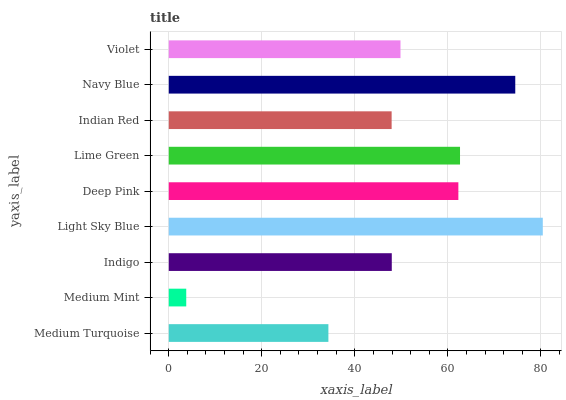Is Medium Mint the minimum?
Answer yes or no. Yes. Is Light Sky Blue the maximum?
Answer yes or no. Yes. Is Indigo the minimum?
Answer yes or no. No. Is Indigo the maximum?
Answer yes or no. No. Is Indigo greater than Medium Mint?
Answer yes or no. Yes. Is Medium Mint less than Indigo?
Answer yes or no. Yes. Is Medium Mint greater than Indigo?
Answer yes or no. No. Is Indigo less than Medium Mint?
Answer yes or no. No. Is Violet the high median?
Answer yes or no. Yes. Is Violet the low median?
Answer yes or no. Yes. Is Light Sky Blue the high median?
Answer yes or no. No. Is Deep Pink the low median?
Answer yes or no. No. 